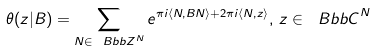<formula> <loc_0><loc_0><loc_500><loc_500>\theta ( { z } | B ) = \sum _ { { N } \in { \ B b b Z } ^ { N } } e ^ { \pi i \langle { N } , B { N } \rangle + 2 \pi i \langle { N , z } \rangle } , \, { z } \in { \ B b b C } ^ { N }</formula> 